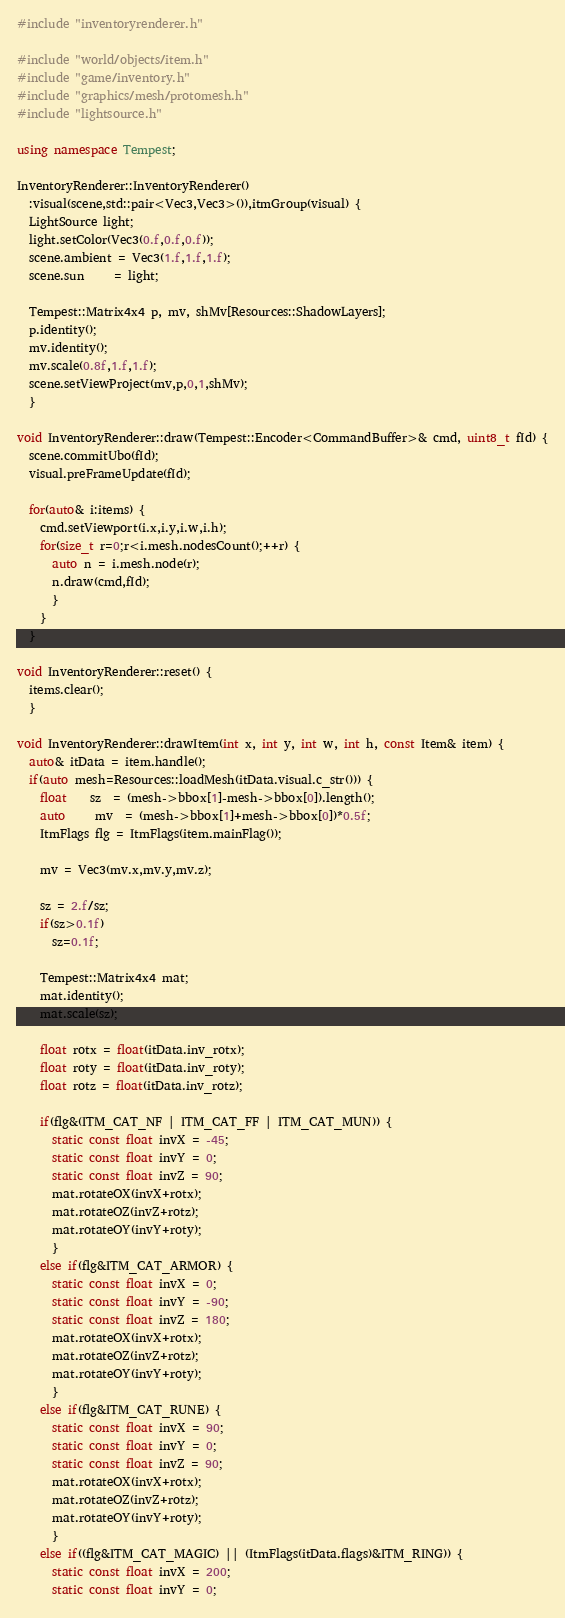Convert code to text. <code><loc_0><loc_0><loc_500><loc_500><_C++_>#include "inventoryrenderer.h"

#include "world/objects/item.h"
#include "game/inventory.h"
#include "graphics/mesh/protomesh.h"
#include "lightsource.h"

using namespace Tempest;

InventoryRenderer::InventoryRenderer()
  :visual(scene,std::pair<Vec3,Vec3>()),itmGroup(visual) {
  LightSource light;
  light.setColor(Vec3(0.f,0.f,0.f));
  scene.ambient = Vec3(1.f,1.f,1.f);
  scene.sun     = light;

  Tempest::Matrix4x4 p, mv, shMv[Resources::ShadowLayers];
  p.identity();
  mv.identity();
  mv.scale(0.8f,1.f,1.f);
  scene.setViewProject(mv,p,0,1,shMv);
  }

void InventoryRenderer::draw(Tempest::Encoder<CommandBuffer>& cmd, uint8_t fId) {
  scene.commitUbo(fId);
  visual.preFrameUpdate(fId);

  for(auto& i:items) {
    cmd.setViewport(i.x,i.y,i.w,i.h);
    for(size_t r=0;r<i.mesh.nodesCount();++r) {
      auto n = i.mesh.node(r);
      n.draw(cmd,fId);
      }
    }
  }

void InventoryRenderer::reset() {
  items.clear();
  }

void InventoryRenderer::drawItem(int x, int y, int w, int h, const Item& item) {
  auto& itData = item.handle();
  if(auto mesh=Resources::loadMesh(itData.visual.c_str())) {
    float    sz  = (mesh->bbox[1]-mesh->bbox[0]).length();
    auto     mv  = (mesh->bbox[1]+mesh->bbox[0])*0.5f;
    ItmFlags flg = ItmFlags(item.mainFlag());

    mv = Vec3(mv.x,mv.y,mv.z);

    sz = 2.f/sz;
    if(sz>0.1f)
      sz=0.1f;

    Tempest::Matrix4x4 mat;
    mat.identity();
    mat.scale(sz);

    float rotx = float(itData.inv_rotx);
    float roty = float(itData.inv_roty);
    float rotz = float(itData.inv_rotz);

    if(flg&(ITM_CAT_NF | ITM_CAT_FF | ITM_CAT_MUN)) {
      static const float invX = -45;
      static const float invY = 0;
      static const float invZ = 90;
      mat.rotateOX(invX+rotx);
      mat.rotateOZ(invZ+rotz);
      mat.rotateOY(invY+roty);
      }
    else if(flg&ITM_CAT_ARMOR) {
      static const float invX = 0;
      static const float invY = -90;
      static const float invZ = 180;
      mat.rotateOX(invX+rotx);
      mat.rotateOZ(invZ+rotz);
      mat.rotateOY(invY+roty);
      }
    else if(flg&ITM_CAT_RUNE) {
      static const float invX = 90;
      static const float invY = 0;
      static const float invZ = 90;
      mat.rotateOX(invX+rotx);
      mat.rotateOZ(invZ+rotz);
      mat.rotateOY(invY+roty);
      }
    else if((flg&ITM_CAT_MAGIC) || (ItmFlags(itData.flags)&ITM_RING)) {
      static const float invX = 200;
      static const float invY = 0;</code> 